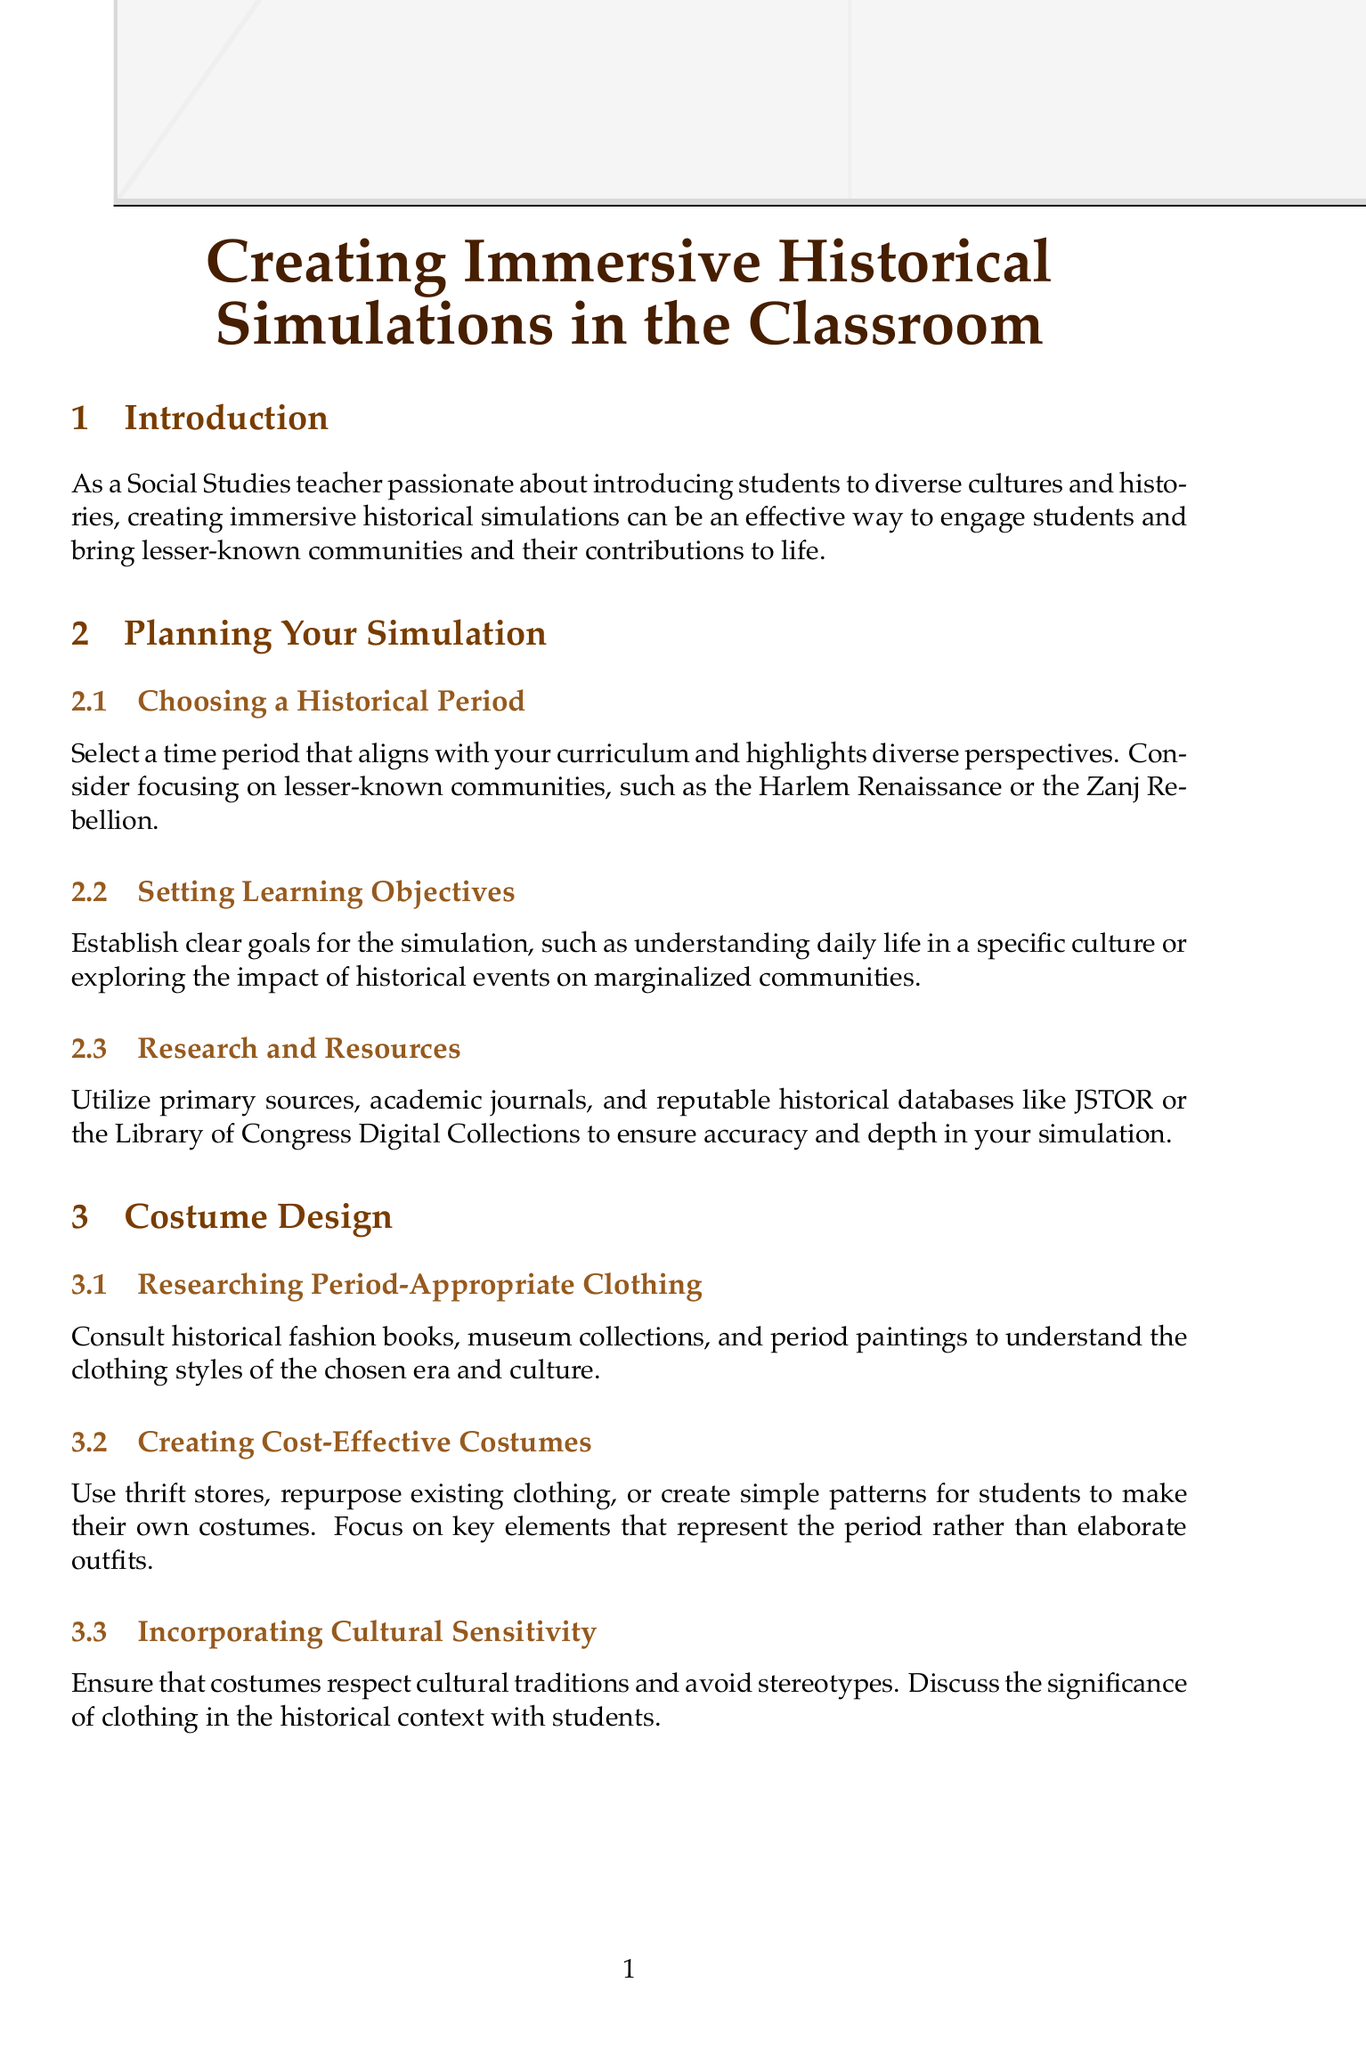What is the title of the manual? The title is clearly stated at the beginning of the document.
Answer: Creating Immersive Historical Simulations in the Classroom Which section discusses costume design? The sections are outlined in the document, and the relevant section is named.
Answer: Costume Design What are two communities mentioned in the planning section? The document lists specific communities to focus on when choosing a historical period.
Answer: Harlem Renaissance, Zanj Rebellion What is one method for character development? The section on role-playing techniques describes ways to assist students in character development.
Answer: Creating historically accurate personas What should be included in the assessment methods? The document suggests various evaluation components to assess student performance during simulations.
Answer: Rubrics, self-assessment, peer-evaluation How many subsections are under "Creating an Immersive Environment"? The total number of subsections under that section is explicitly mentioned.
Answer: Three What is suggested to enhance the immersive experience? The document provides ideas for improving the classroom atmosphere during simulations.
Answer: Period-appropriate music and ambient sounds Which tool is mentioned for technology integration? The section covers various tools to utilize for creating an immersive experience in historical simulations.
Answer: Google Expeditions What is a key focus when creating costumes? The document emphasizes a particular aspect of costume creation that is important during simulations.
Answer: Cultural sensitivity 